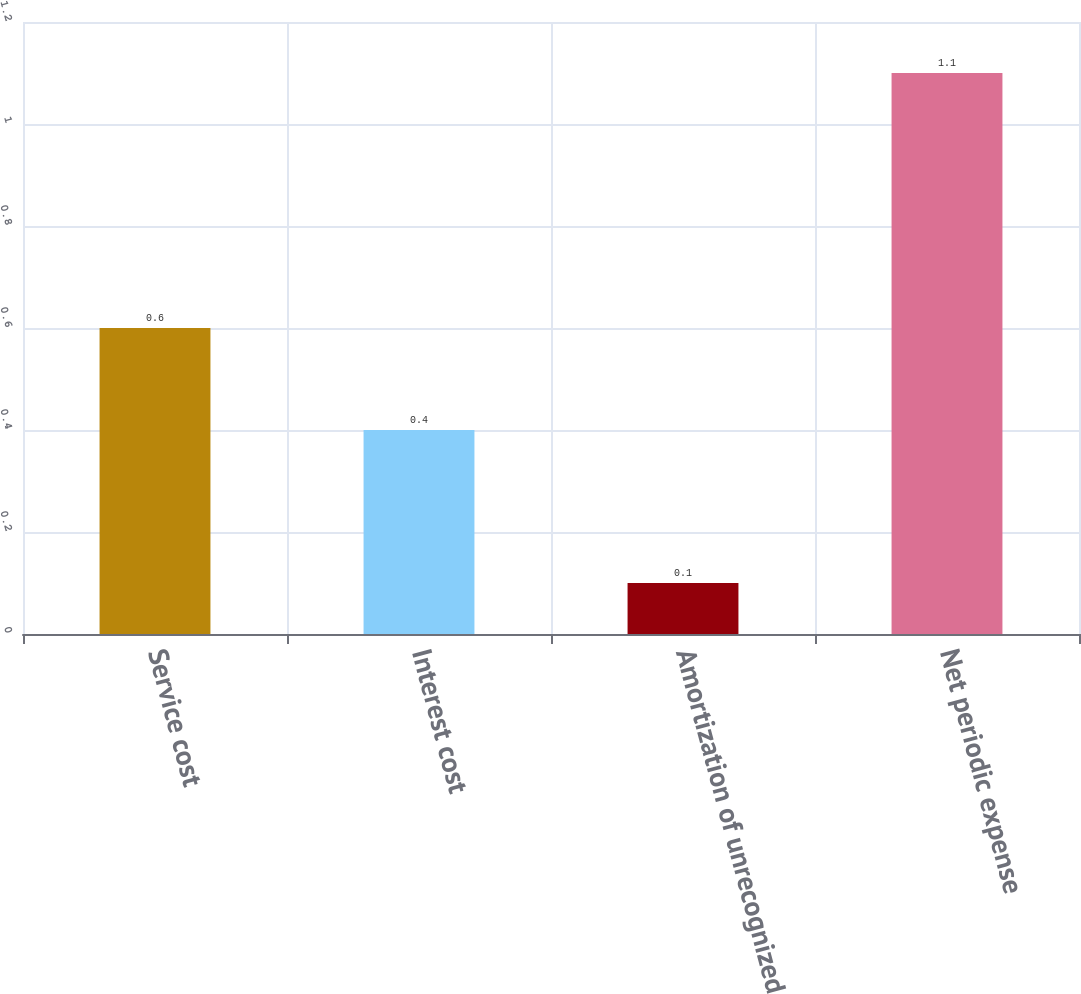<chart> <loc_0><loc_0><loc_500><loc_500><bar_chart><fcel>Service cost<fcel>Interest cost<fcel>Amortization of unrecognized<fcel>Net periodic expense<nl><fcel>0.6<fcel>0.4<fcel>0.1<fcel>1.1<nl></chart> 